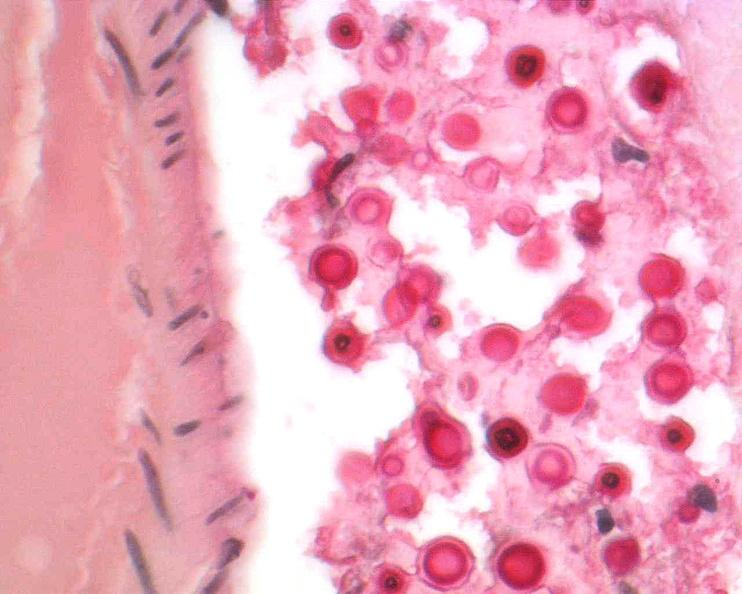what does this image show?
Answer the question using a single word or phrase. Brain 